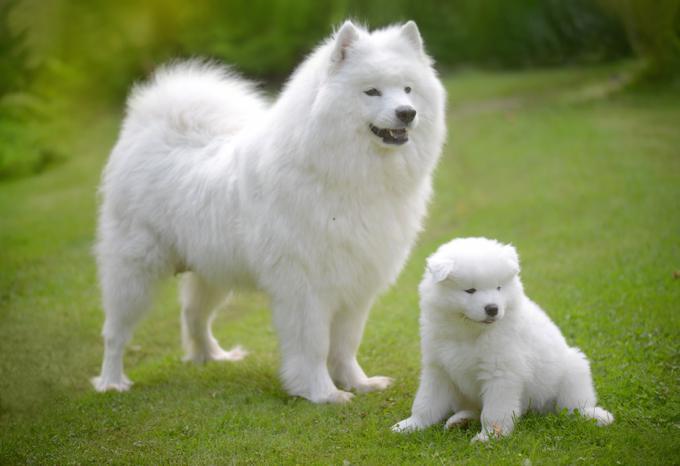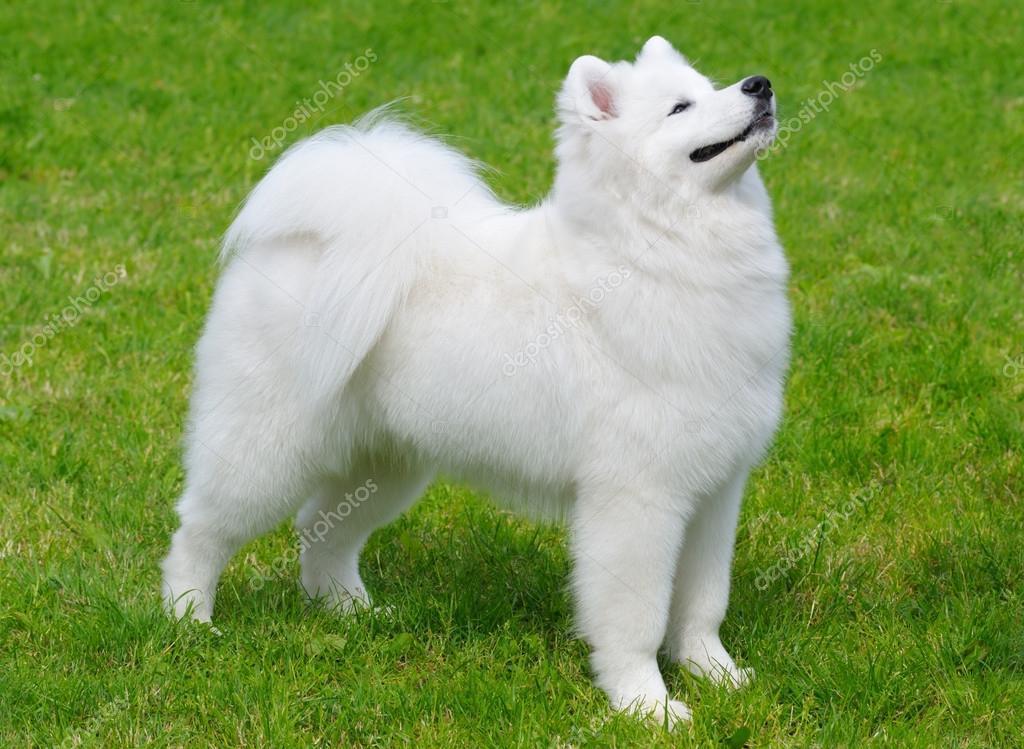The first image is the image on the left, the second image is the image on the right. Assess this claim about the two images: "There are no more than three dogs". Correct or not? Answer yes or no. Yes. 